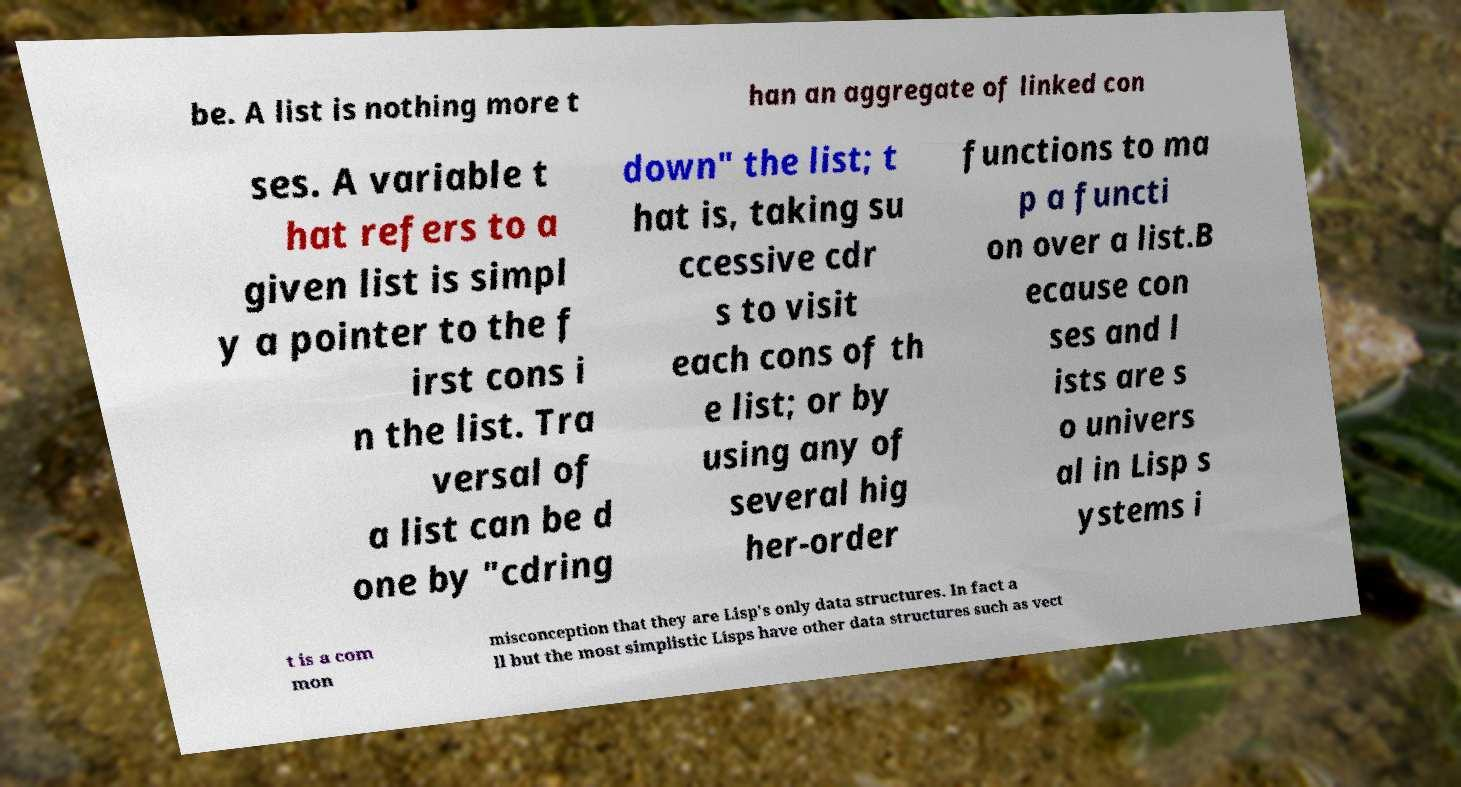I need the written content from this picture converted into text. Can you do that? be. A list is nothing more t han an aggregate of linked con ses. A variable t hat refers to a given list is simpl y a pointer to the f irst cons i n the list. Tra versal of a list can be d one by "cdring down" the list; t hat is, taking su ccessive cdr s to visit each cons of th e list; or by using any of several hig her-order functions to ma p a functi on over a list.B ecause con ses and l ists are s o univers al in Lisp s ystems i t is a com mon misconception that they are Lisp's only data structures. In fact a ll but the most simplistic Lisps have other data structures such as vect 